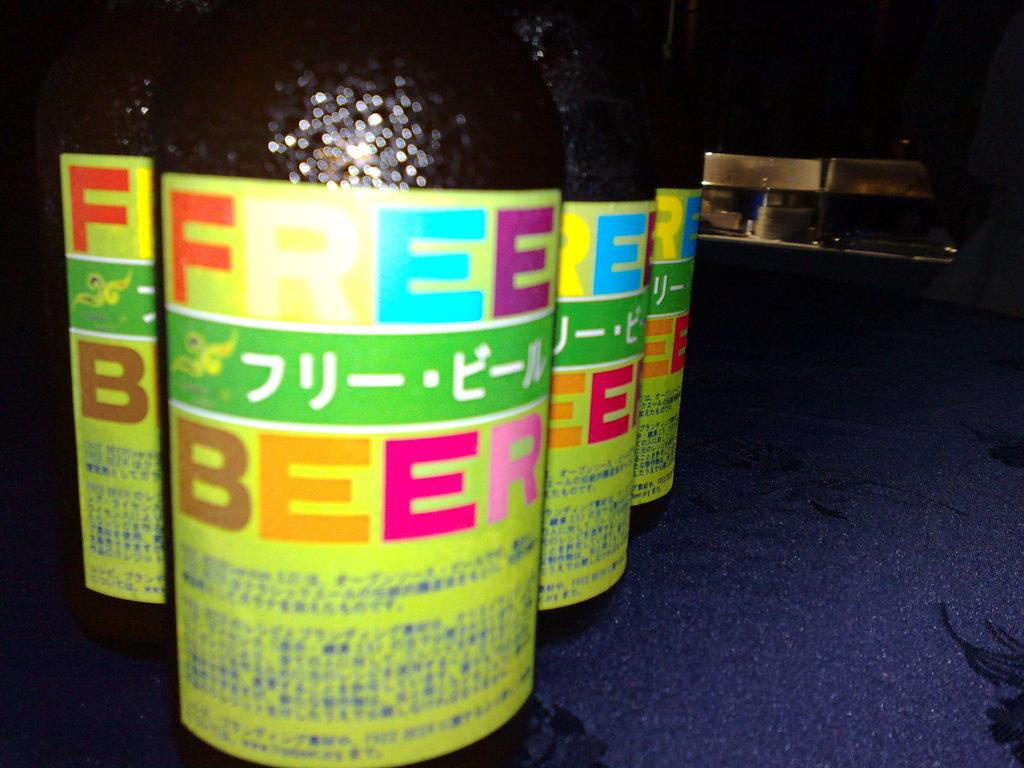Provide a one-sentence caption for the provided image. 4 bottles of Free Beer with colorful labels. 